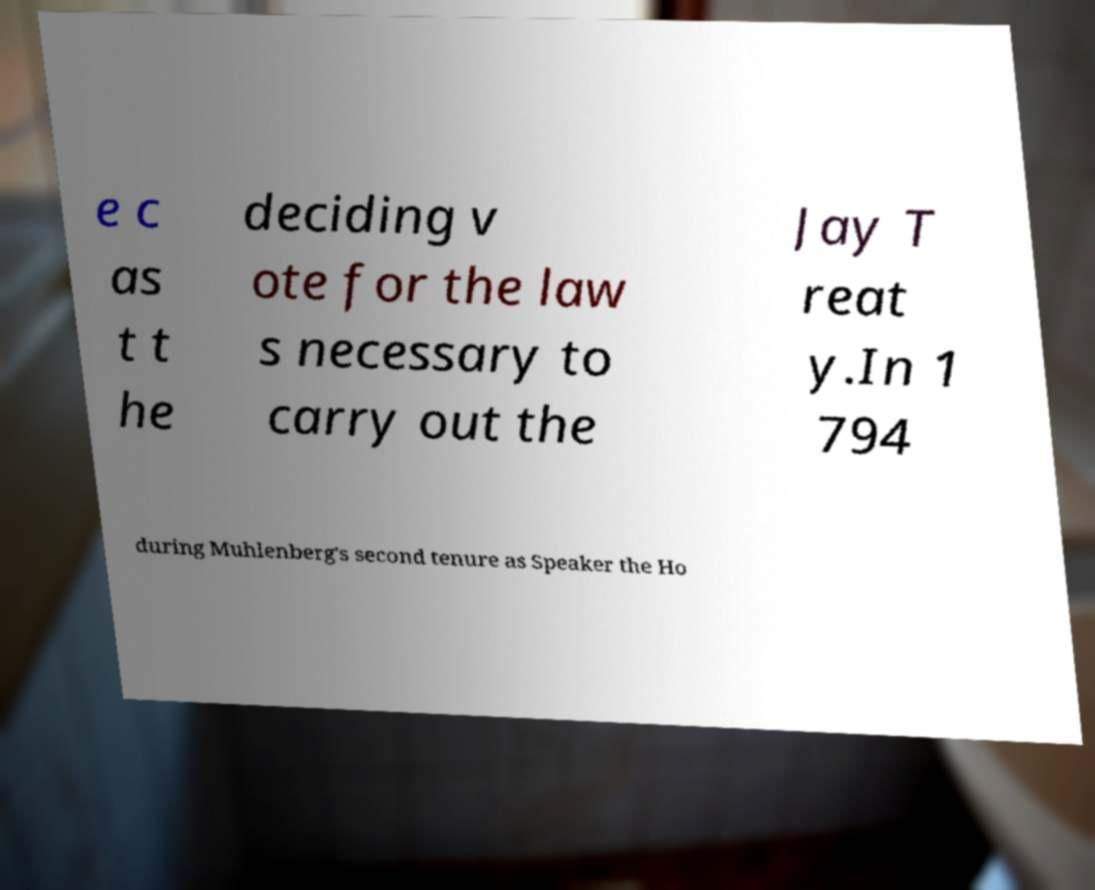Could you assist in decoding the text presented in this image and type it out clearly? e c as t t he deciding v ote for the law s necessary to carry out the Jay T reat y.In 1 794 during Muhlenberg's second tenure as Speaker the Ho 